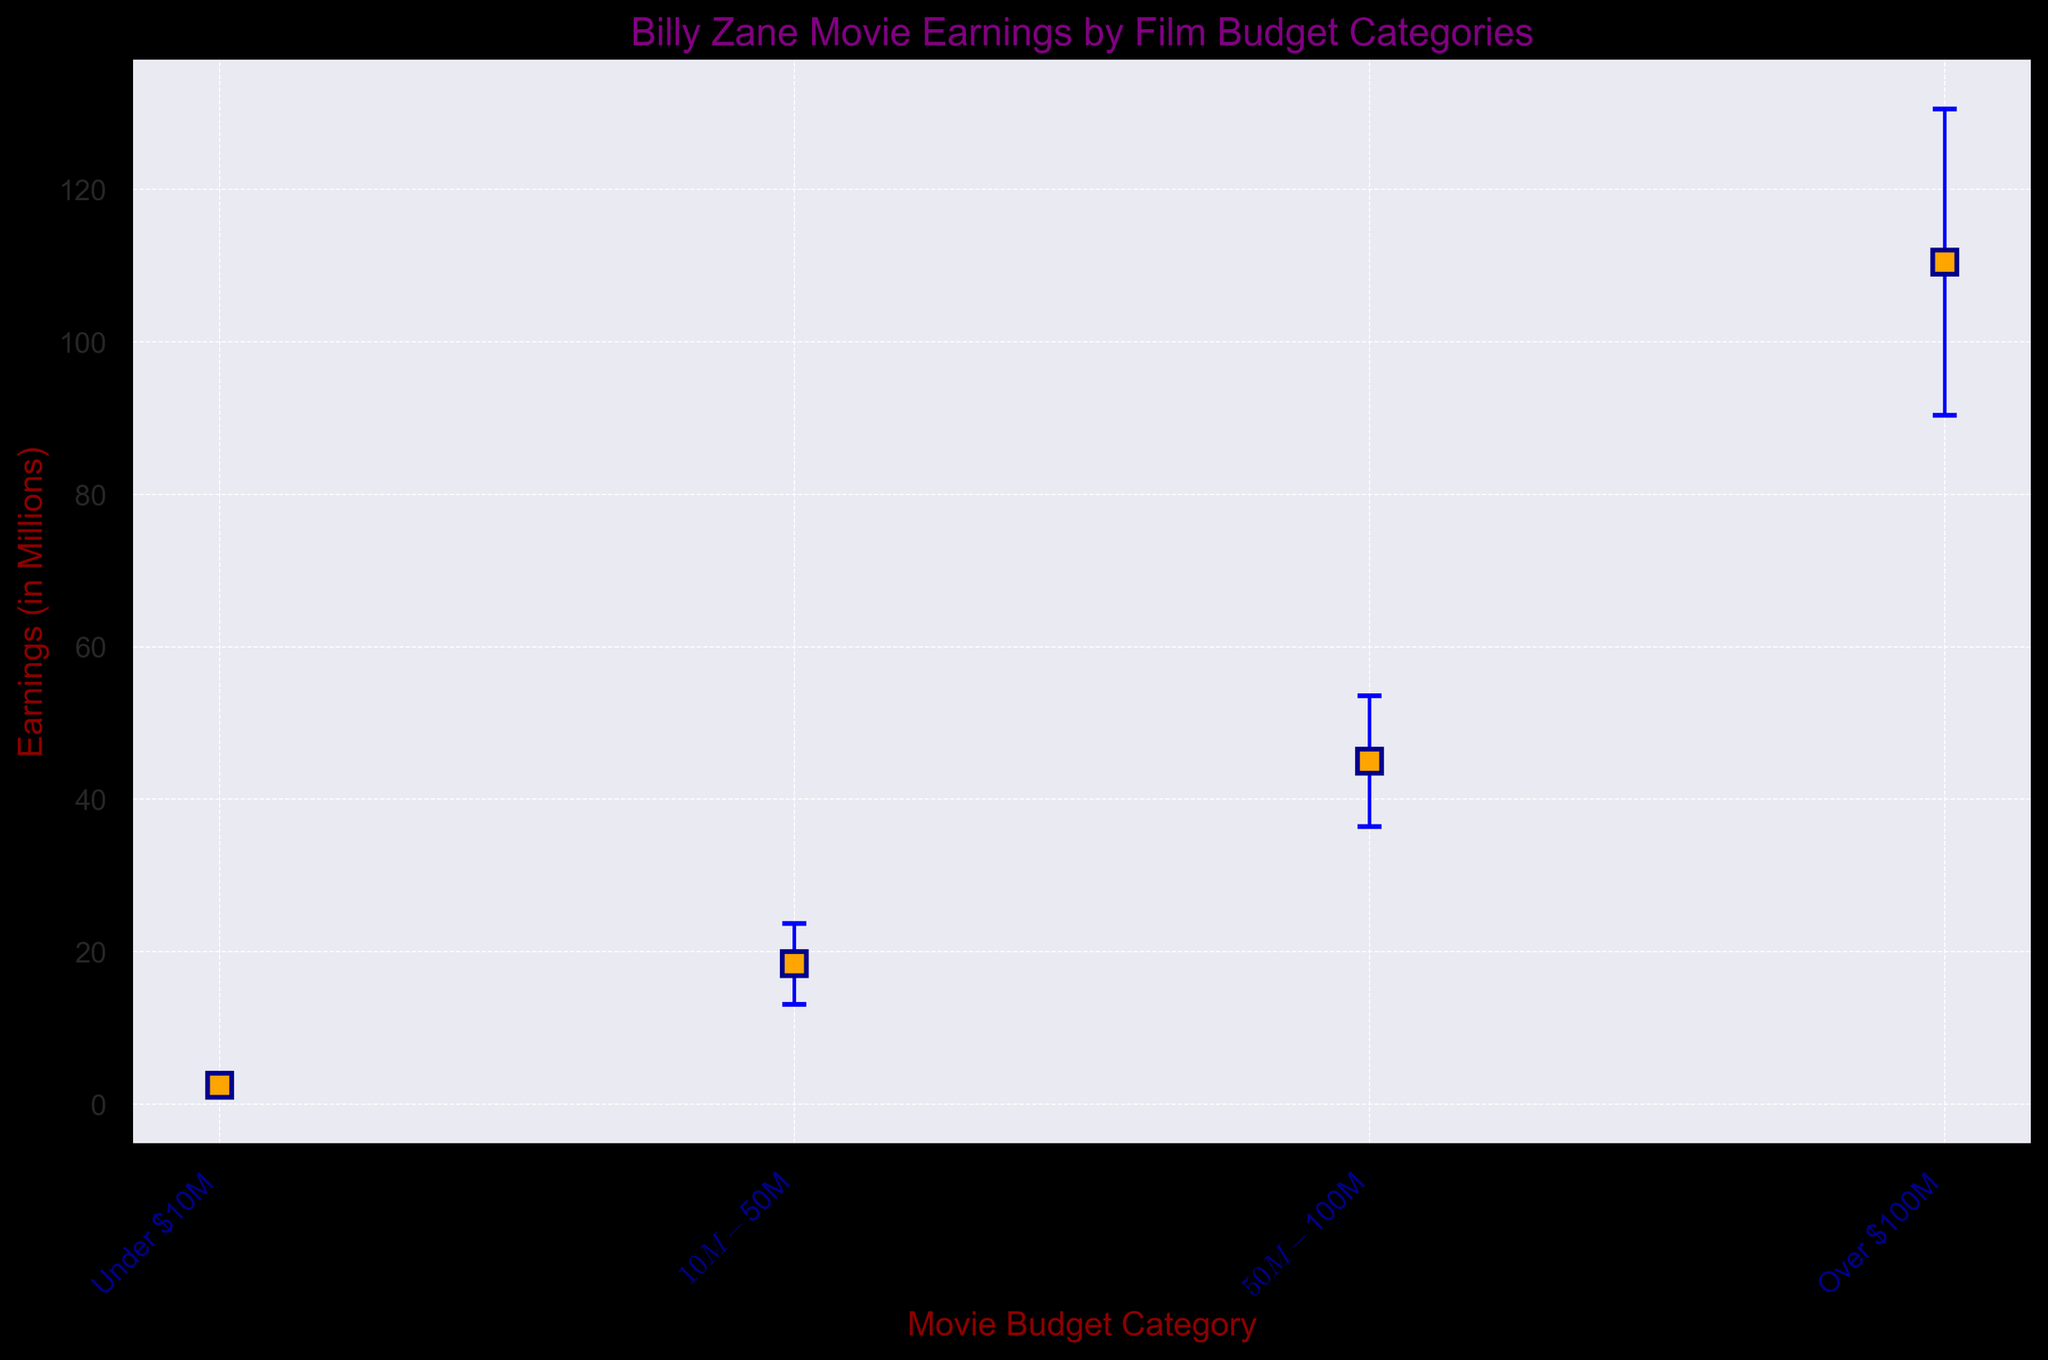What is the highest mean earnings among the budget categories? First, look at the mean earnings of each budget category. The highest value is observed in the "Over $100M" category with mean earnings of 110.5 million dollars.
Answer: 110.5 million dollars How does the standard deviation of earnings for movies with budgets over $100M compare to movies with budgets under $10M? The standard deviation for "Over $100M" is 20.1, while for "Under $10M" it is 1.2. The standard deviation for "Over $100M" is higher than that for "Under $10M".
Answer: Higher What is the difference in mean earnings between the $50M-$100M and $10M-$50M budget categories? The mean earnings for "$50M-$100M" is 45.0, and for "$10M-$50M" it is 18.4. The difference is 45.0 - 18.4.
Answer: 26.6 million dollars Which budget category has the smallest mean earnings? By observing the mean earnings in each budget category, "Under $10M" has the smallest mean earnings of 2.5 million dollars.
Answer: Under $10M What are the error bar extents for the "Over $100M" budget category? The mean earnings is 110.5 million dollars with a standard deviation of 20.1. Therefore, the error bars range from 110.5 - 20.1 to 110.5 + 20.1.
Answer: 90.4 to 130.6 million dollars 